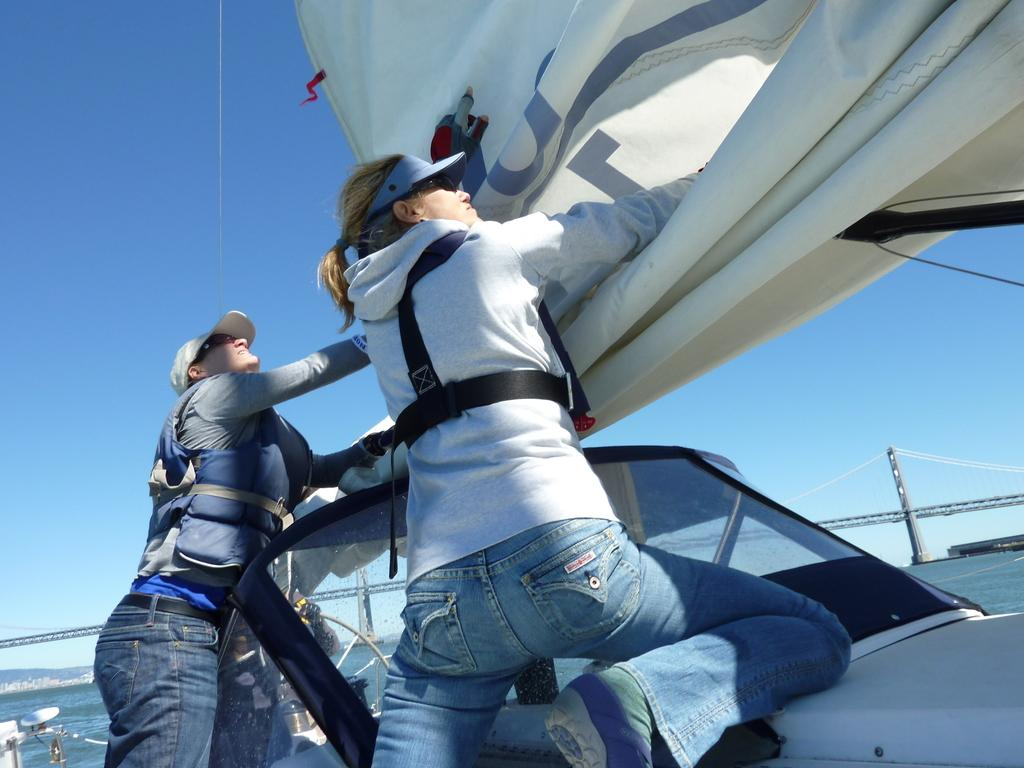What are the people in the image doing? The people are standing on a vehicle. What are the people holding in the image? The people are holding a parachute-like object. What can be seen in the background of the image? There is a river, a bridge, and the sky visible in the background of the image. What type of animal is giving birth in the image? There is no animal present in the image, nor is there any indication of a birth taking place. 